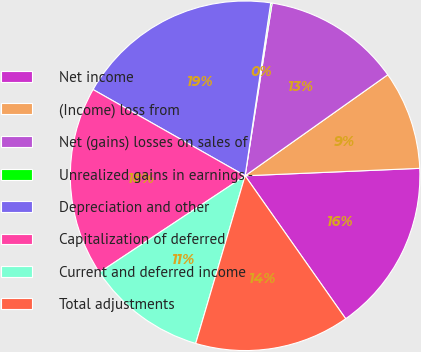<chart> <loc_0><loc_0><loc_500><loc_500><pie_chart><fcel>Net income<fcel>(Income) loss from<fcel>Net (gains) losses on sales of<fcel>Unrealized gains in earnings -<fcel>Depreciation and other<fcel>Capitalization of deferred<fcel>Current and deferred income<fcel>Total adjustments<nl><fcel>15.92%<fcel>9.13%<fcel>12.72%<fcel>0.13%<fcel>19.13%<fcel>17.53%<fcel>11.12%<fcel>14.32%<nl></chart> 